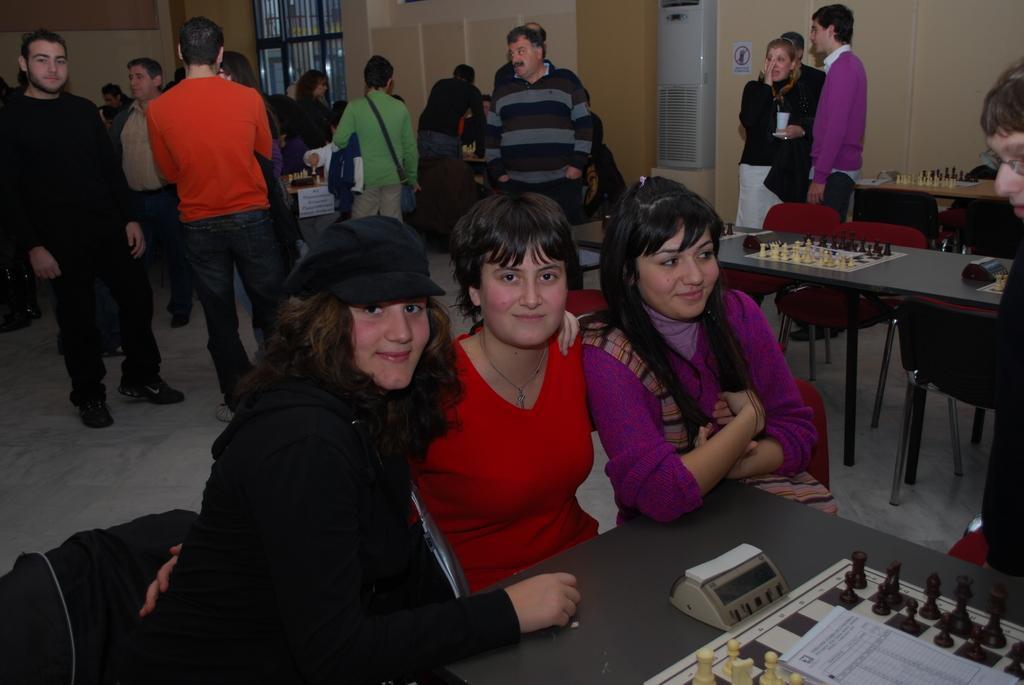Can you describe this image briefly? The image is inside the room. In the image there are three people sitting on chair in front of a table, on table we can see a stop watch,chess board,paper and we can also see group of people are standing in background. On right there is a air conditioner,wall which is in cream color in background there is a window. 